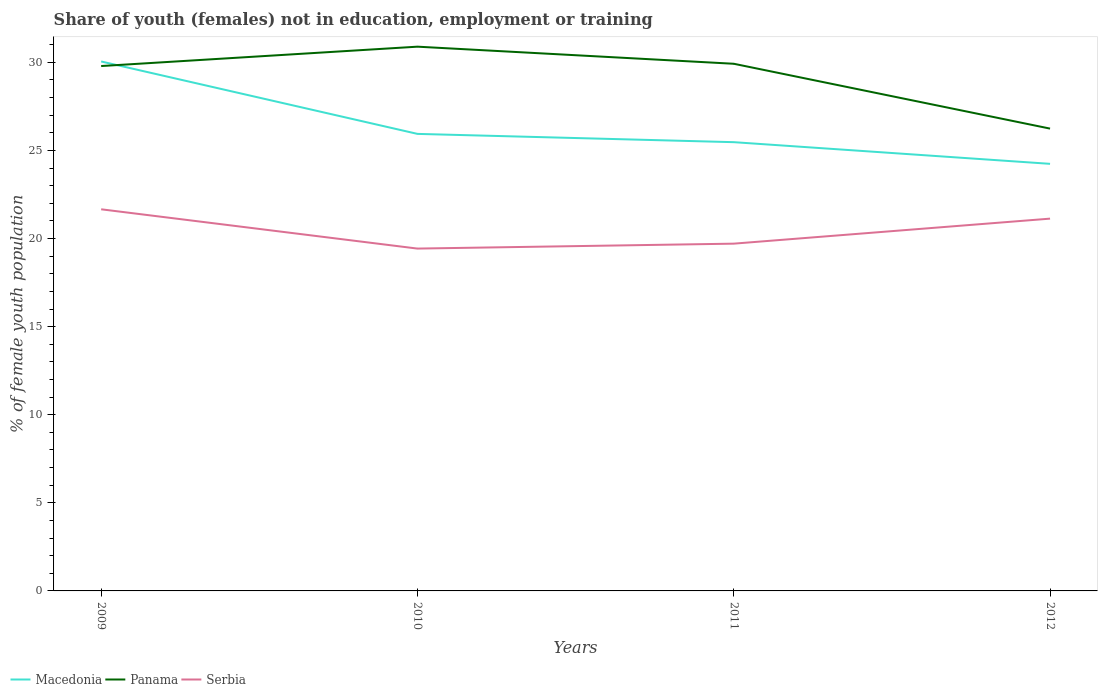Is the number of lines equal to the number of legend labels?
Your answer should be compact. Yes. Across all years, what is the maximum percentage of unemployed female population in in Panama?
Make the answer very short. 26.24. What is the total percentage of unemployed female population in in Macedonia in the graph?
Ensure brevity in your answer.  4.58. What is the difference between the highest and the second highest percentage of unemployed female population in in Macedonia?
Provide a short and direct response. 5.81. How many years are there in the graph?
Offer a terse response. 4. Are the values on the major ticks of Y-axis written in scientific E-notation?
Make the answer very short. No. Does the graph contain any zero values?
Offer a very short reply. No. What is the title of the graph?
Your answer should be compact. Share of youth (females) not in education, employment or training. What is the label or title of the Y-axis?
Provide a succinct answer. % of female youth population. What is the % of female youth population in Macedonia in 2009?
Make the answer very short. 30.05. What is the % of female youth population of Panama in 2009?
Offer a very short reply. 29.79. What is the % of female youth population of Serbia in 2009?
Make the answer very short. 21.66. What is the % of female youth population in Macedonia in 2010?
Provide a succinct answer. 25.94. What is the % of female youth population in Panama in 2010?
Ensure brevity in your answer.  30.89. What is the % of female youth population in Serbia in 2010?
Provide a short and direct response. 19.43. What is the % of female youth population in Macedonia in 2011?
Your response must be concise. 25.47. What is the % of female youth population of Panama in 2011?
Your response must be concise. 29.92. What is the % of female youth population of Serbia in 2011?
Provide a succinct answer. 19.71. What is the % of female youth population in Macedonia in 2012?
Ensure brevity in your answer.  24.24. What is the % of female youth population in Panama in 2012?
Offer a terse response. 26.24. What is the % of female youth population of Serbia in 2012?
Your response must be concise. 21.13. Across all years, what is the maximum % of female youth population of Macedonia?
Offer a terse response. 30.05. Across all years, what is the maximum % of female youth population in Panama?
Your response must be concise. 30.89. Across all years, what is the maximum % of female youth population of Serbia?
Ensure brevity in your answer.  21.66. Across all years, what is the minimum % of female youth population in Macedonia?
Offer a terse response. 24.24. Across all years, what is the minimum % of female youth population in Panama?
Give a very brief answer. 26.24. Across all years, what is the minimum % of female youth population in Serbia?
Offer a very short reply. 19.43. What is the total % of female youth population of Macedonia in the graph?
Your answer should be compact. 105.7. What is the total % of female youth population of Panama in the graph?
Your answer should be very brief. 116.84. What is the total % of female youth population of Serbia in the graph?
Your response must be concise. 81.93. What is the difference between the % of female youth population in Macedonia in 2009 and that in 2010?
Your answer should be very brief. 4.11. What is the difference between the % of female youth population in Serbia in 2009 and that in 2010?
Offer a very short reply. 2.23. What is the difference between the % of female youth population in Macedonia in 2009 and that in 2011?
Provide a short and direct response. 4.58. What is the difference between the % of female youth population in Panama in 2009 and that in 2011?
Your answer should be compact. -0.13. What is the difference between the % of female youth population in Serbia in 2009 and that in 2011?
Give a very brief answer. 1.95. What is the difference between the % of female youth population in Macedonia in 2009 and that in 2012?
Provide a short and direct response. 5.81. What is the difference between the % of female youth population in Panama in 2009 and that in 2012?
Your answer should be compact. 3.55. What is the difference between the % of female youth population in Serbia in 2009 and that in 2012?
Offer a very short reply. 0.53. What is the difference between the % of female youth population in Macedonia in 2010 and that in 2011?
Provide a short and direct response. 0.47. What is the difference between the % of female youth population in Serbia in 2010 and that in 2011?
Your answer should be compact. -0.28. What is the difference between the % of female youth population in Panama in 2010 and that in 2012?
Offer a very short reply. 4.65. What is the difference between the % of female youth population in Macedonia in 2011 and that in 2012?
Make the answer very short. 1.23. What is the difference between the % of female youth population of Panama in 2011 and that in 2012?
Offer a terse response. 3.68. What is the difference between the % of female youth population in Serbia in 2011 and that in 2012?
Provide a short and direct response. -1.42. What is the difference between the % of female youth population in Macedonia in 2009 and the % of female youth population in Panama in 2010?
Your answer should be very brief. -0.84. What is the difference between the % of female youth population in Macedonia in 2009 and the % of female youth population in Serbia in 2010?
Your response must be concise. 10.62. What is the difference between the % of female youth population of Panama in 2009 and the % of female youth population of Serbia in 2010?
Offer a very short reply. 10.36. What is the difference between the % of female youth population in Macedonia in 2009 and the % of female youth population in Panama in 2011?
Ensure brevity in your answer.  0.13. What is the difference between the % of female youth population in Macedonia in 2009 and the % of female youth population in Serbia in 2011?
Your response must be concise. 10.34. What is the difference between the % of female youth population in Panama in 2009 and the % of female youth population in Serbia in 2011?
Make the answer very short. 10.08. What is the difference between the % of female youth population of Macedonia in 2009 and the % of female youth population of Panama in 2012?
Ensure brevity in your answer.  3.81. What is the difference between the % of female youth population of Macedonia in 2009 and the % of female youth population of Serbia in 2012?
Provide a succinct answer. 8.92. What is the difference between the % of female youth population in Panama in 2009 and the % of female youth population in Serbia in 2012?
Offer a terse response. 8.66. What is the difference between the % of female youth population in Macedonia in 2010 and the % of female youth population in Panama in 2011?
Ensure brevity in your answer.  -3.98. What is the difference between the % of female youth population of Macedonia in 2010 and the % of female youth population of Serbia in 2011?
Your answer should be compact. 6.23. What is the difference between the % of female youth population of Panama in 2010 and the % of female youth population of Serbia in 2011?
Offer a terse response. 11.18. What is the difference between the % of female youth population in Macedonia in 2010 and the % of female youth population in Panama in 2012?
Make the answer very short. -0.3. What is the difference between the % of female youth population of Macedonia in 2010 and the % of female youth population of Serbia in 2012?
Your answer should be very brief. 4.81. What is the difference between the % of female youth population in Panama in 2010 and the % of female youth population in Serbia in 2012?
Provide a succinct answer. 9.76. What is the difference between the % of female youth population of Macedonia in 2011 and the % of female youth population of Panama in 2012?
Your answer should be very brief. -0.77. What is the difference between the % of female youth population of Macedonia in 2011 and the % of female youth population of Serbia in 2012?
Your answer should be compact. 4.34. What is the difference between the % of female youth population in Panama in 2011 and the % of female youth population in Serbia in 2012?
Your answer should be compact. 8.79. What is the average % of female youth population of Macedonia per year?
Give a very brief answer. 26.43. What is the average % of female youth population in Panama per year?
Provide a short and direct response. 29.21. What is the average % of female youth population in Serbia per year?
Give a very brief answer. 20.48. In the year 2009, what is the difference between the % of female youth population in Macedonia and % of female youth population in Panama?
Keep it short and to the point. 0.26. In the year 2009, what is the difference between the % of female youth population of Macedonia and % of female youth population of Serbia?
Give a very brief answer. 8.39. In the year 2009, what is the difference between the % of female youth population in Panama and % of female youth population in Serbia?
Give a very brief answer. 8.13. In the year 2010, what is the difference between the % of female youth population in Macedonia and % of female youth population in Panama?
Provide a short and direct response. -4.95. In the year 2010, what is the difference between the % of female youth population in Macedonia and % of female youth population in Serbia?
Your answer should be compact. 6.51. In the year 2010, what is the difference between the % of female youth population of Panama and % of female youth population of Serbia?
Ensure brevity in your answer.  11.46. In the year 2011, what is the difference between the % of female youth population of Macedonia and % of female youth population of Panama?
Offer a very short reply. -4.45. In the year 2011, what is the difference between the % of female youth population of Macedonia and % of female youth population of Serbia?
Your answer should be very brief. 5.76. In the year 2011, what is the difference between the % of female youth population in Panama and % of female youth population in Serbia?
Keep it short and to the point. 10.21. In the year 2012, what is the difference between the % of female youth population in Macedonia and % of female youth population in Serbia?
Offer a very short reply. 3.11. In the year 2012, what is the difference between the % of female youth population in Panama and % of female youth population in Serbia?
Give a very brief answer. 5.11. What is the ratio of the % of female youth population of Macedonia in 2009 to that in 2010?
Give a very brief answer. 1.16. What is the ratio of the % of female youth population in Panama in 2009 to that in 2010?
Your answer should be compact. 0.96. What is the ratio of the % of female youth population of Serbia in 2009 to that in 2010?
Ensure brevity in your answer.  1.11. What is the ratio of the % of female youth population in Macedonia in 2009 to that in 2011?
Provide a short and direct response. 1.18. What is the ratio of the % of female youth population of Panama in 2009 to that in 2011?
Your answer should be compact. 1. What is the ratio of the % of female youth population of Serbia in 2009 to that in 2011?
Give a very brief answer. 1.1. What is the ratio of the % of female youth population of Macedonia in 2009 to that in 2012?
Your answer should be very brief. 1.24. What is the ratio of the % of female youth population in Panama in 2009 to that in 2012?
Offer a terse response. 1.14. What is the ratio of the % of female youth population of Serbia in 2009 to that in 2012?
Ensure brevity in your answer.  1.03. What is the ratio of the % of female youth population of Macedonia in 2010 to that in 2011?
Your answer should be compact. 1.02. What is the ratio of the % of female youth population in Panama in 2010 to that in 2011?
Provide a short and direct response. 1.03. What is the ratio of the % of female youth population of Serbia in 2010 to that in 2011?
Your answer should be compact. 0.99. What is the ratio of the % of female youth population in Macedonia in 2010 to that in 2012?
Your answer should be compact. 1.07. What is the ratio of the % of female youth population in Panama in 2010 to that in 2012?
Give a very brief answer. 1.18. What is the ratio of the % of female youth population in Serbia in 2010 to that in 2012?
Offer a very short reply. 0.92. What is the ratio of the % of female youth population of Macedonia in 2011 to that in 2012?
Ensure brevity in your answer.  1.05. What is the ratio of the % of female youth population of Panama in 2011 to that in 2012?
Ensure brevity in your answer.  1.14. What is the ratio of the % of female youth population in Serbia in 2011 to that in 2012?
Make the answer very short. 0.93. What is the difference between the highest and the second highest % of female youth population in Macedonia?
Provide a succinct answer. 4.11. What is the difference between the highest and the second highest % of female youth population of Panama?
Keep it short and to the point. 0.97. What is the difference between the highest and the second highest % of female youth population of Serbia?
Offer a very short reply. 0.53. What is the difference between the highest and the lowest % of female youth population in Macedonia?
Keep it short and to the point. 5.81. What is the difference between the highest and the lowest % of female youth population in Panama?
Make the answer very short. 4.65. What is the difference between the highest and the lowest % of female youth population in Serbia?
Give a very brief answer. 2.23. 